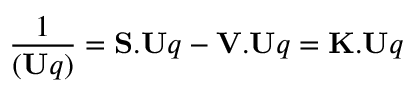<formula> <loc_0><loc_0><loc_500><loc_500>{ \frac { 1 } { ( U q ) } } = S . U q - V . U q = K . U q</formula> 